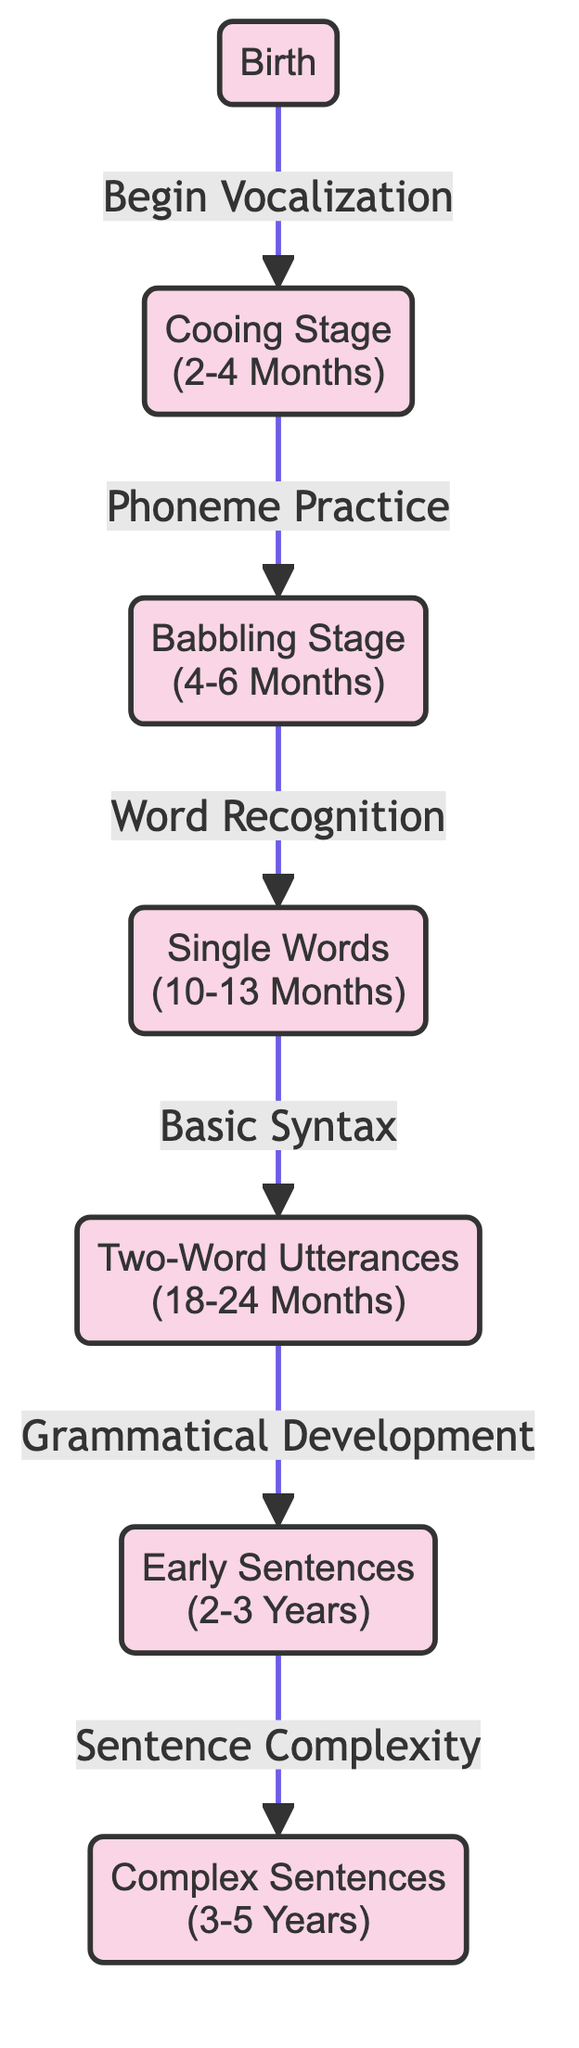What's the first cognitive milestone in the diagram? The diagram starts at the "Birth" node, which represents the first cognitive milestone, indicating the beginning of vocalization.
Answer: Birth How many nodes are present in the diagram? By counting each milestone and transition represented in the diagram, there are a total of 7 milestones and 6 transitions, summing up to 13 nodes.
Answer: 13 What is the transition from "Two-Word Utterances"? The arrow indicates that "Two-Word Utterances" leads to "Early Sentences," which reflects the developmental transition that occurs in this stage.
Answer: Grammatical Development What cognitive milestone follows "Babbling Stage"? The diagram shows an arrow leading from "Babbling Stage" to "Single Words," indicating that "Single Words" is the next milestone after "Babbling Stage."
Answer: Single Words What is the last cognitive milestone before "Complex Sentences"? Looking at the flow of the diagram, "Early Sentences" is the milestone that comes directly before "Complex Sentences," marking a step in sentence complexity development.
Answer: Early Sentences What is the relationship between "Cooing Stage" and "Babbling Stage"? The arrow between the two nodes signifies that the progression from "Cooing Stage" relates to "Phoneme Practice," which is necessary for proceeding to the "Babbling Stage."
Answer: Phoneme Practice Which milestone indicates the use of basic syntax? The transition from "Single Words" to "Two-Word Utterances" signifies that "Two-Word Utterances" is where basic syntax begins to emerge in early language development.
Answer: Two-Word Utterances How many transitions are indicated in the diagram? By examining the diagram, there are a total of 6 transitions that connect the cognitive milestones, representing the development process.
Answer: 6 What is the significance of the "Complex Sentences" milestone? "Complex Sentences" is positioned as the final milestone in the chain, indicating advanced sentence complexity development during early childhood.
Answer: Sentence Complexity 